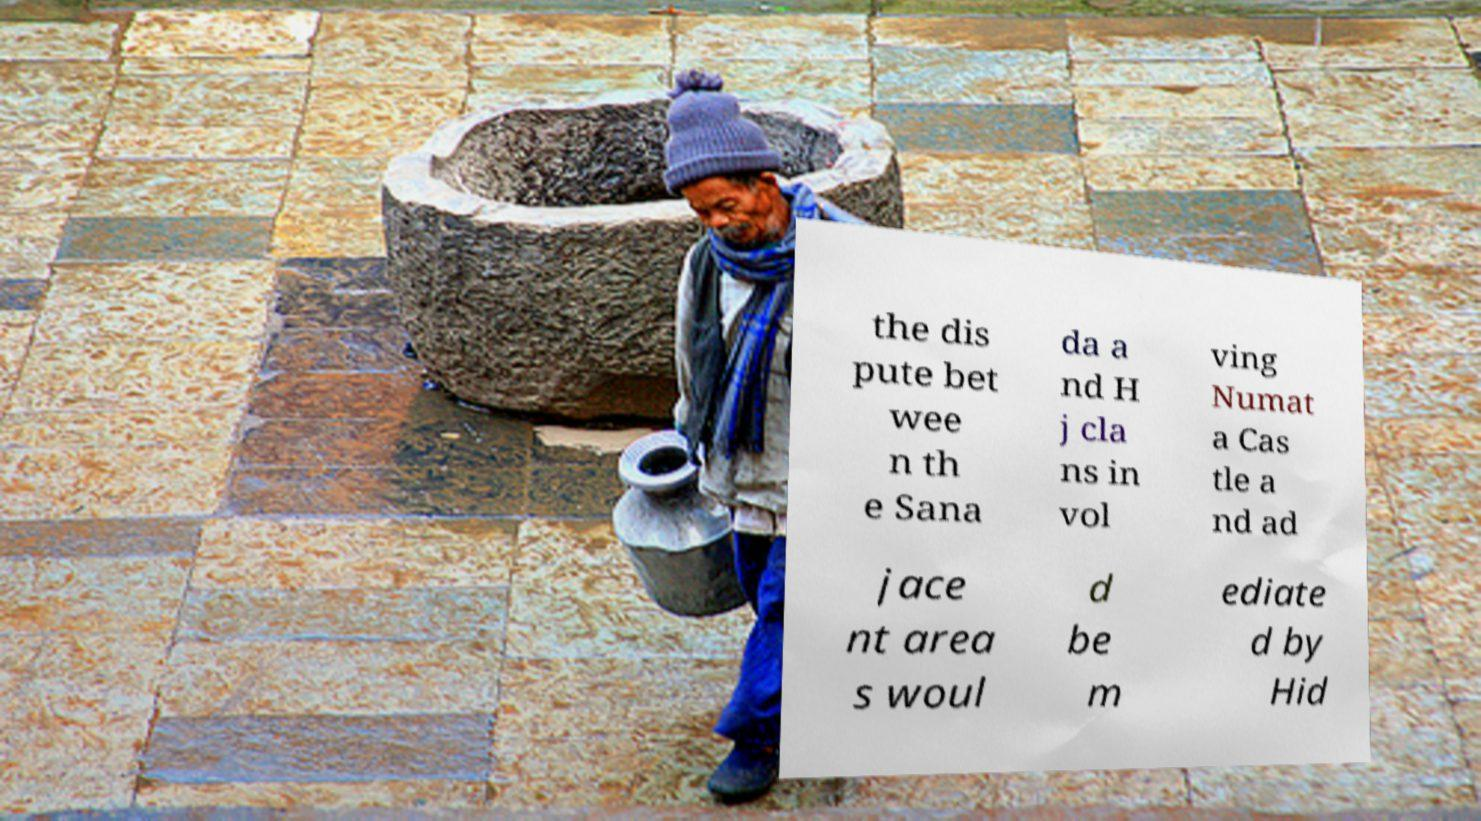Can you accurately transcribe the text from the provided image for me? the dis pute bet wee n th e Sana da a nd H j cla ns in vol ving Numat a Cas tle a nd ad jace nt area s woul d be m ediate d by Hid 